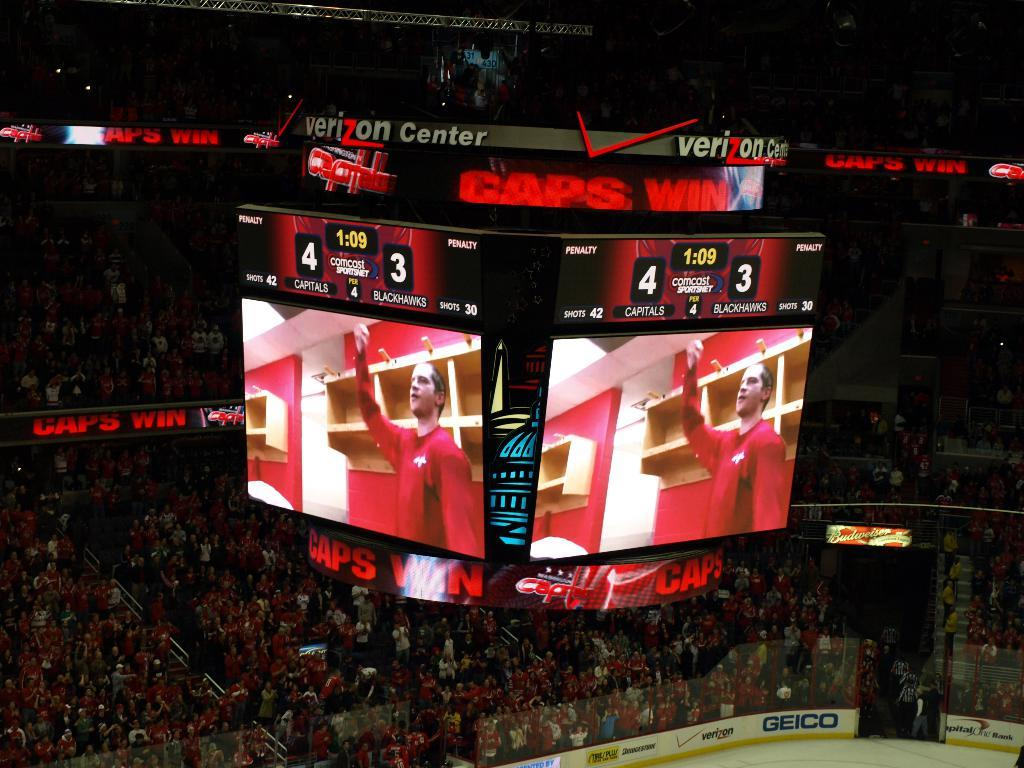<image>
Describe the image concisely. A hockey game with Geico and Capital One signs on the stadium walls. 